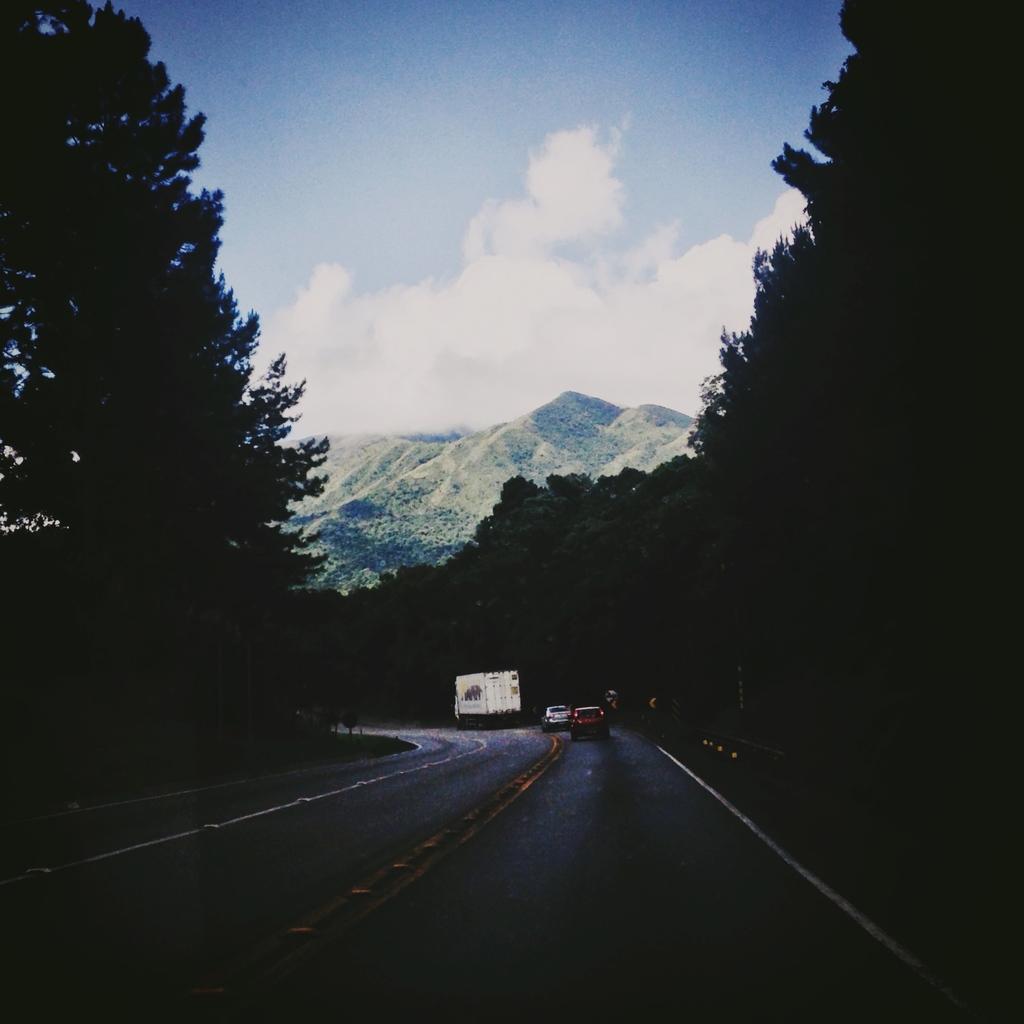How would you summarize this image in a sentence or two? In the image there is a road and there are few vehicles on the road, around the road there are many trees and in the background there is a mountain. 